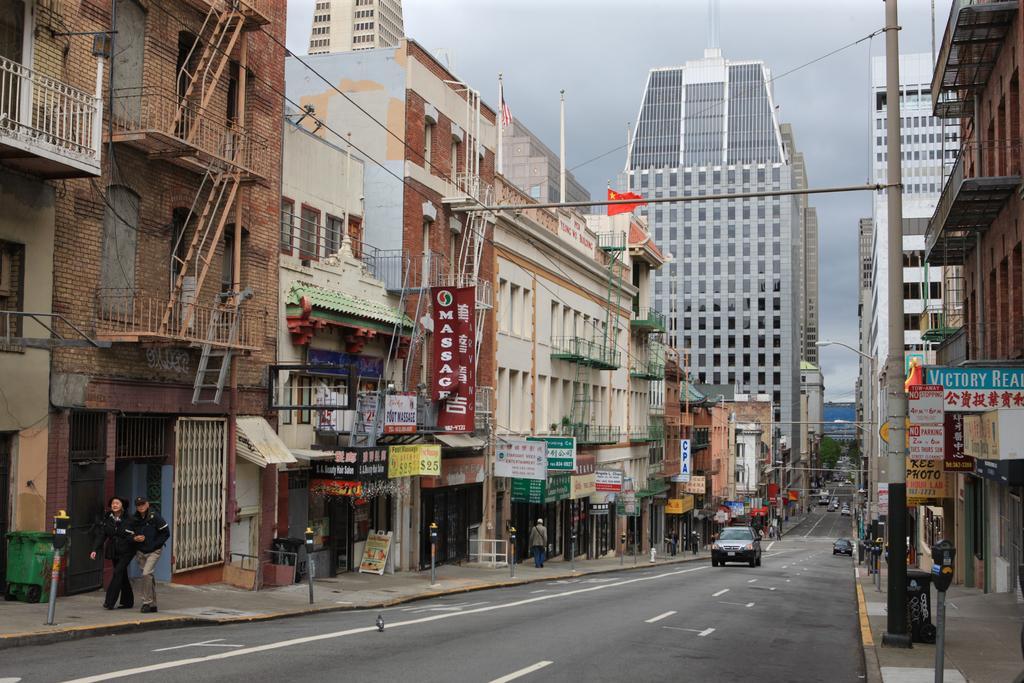Describe this image in one or two sentences. In this picture we can see vehicles on the road, beside this road we can see people, buildings, posters, electric poles, trees and some objects and we can see sky in the background. 